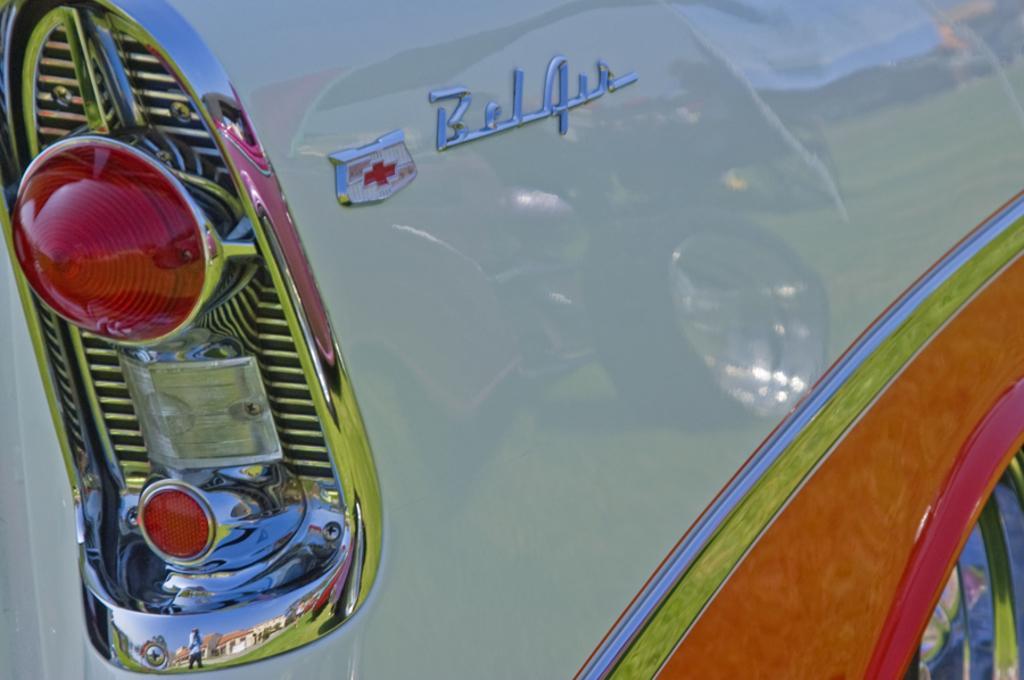In one or two sentences, can you explain what this image depicts? In this image we can see one of the portion of the car in which bottom we can see car's wheel. And left side we can see two red lights and the border ends with the silver coloring. And in the middle we can see some text. 